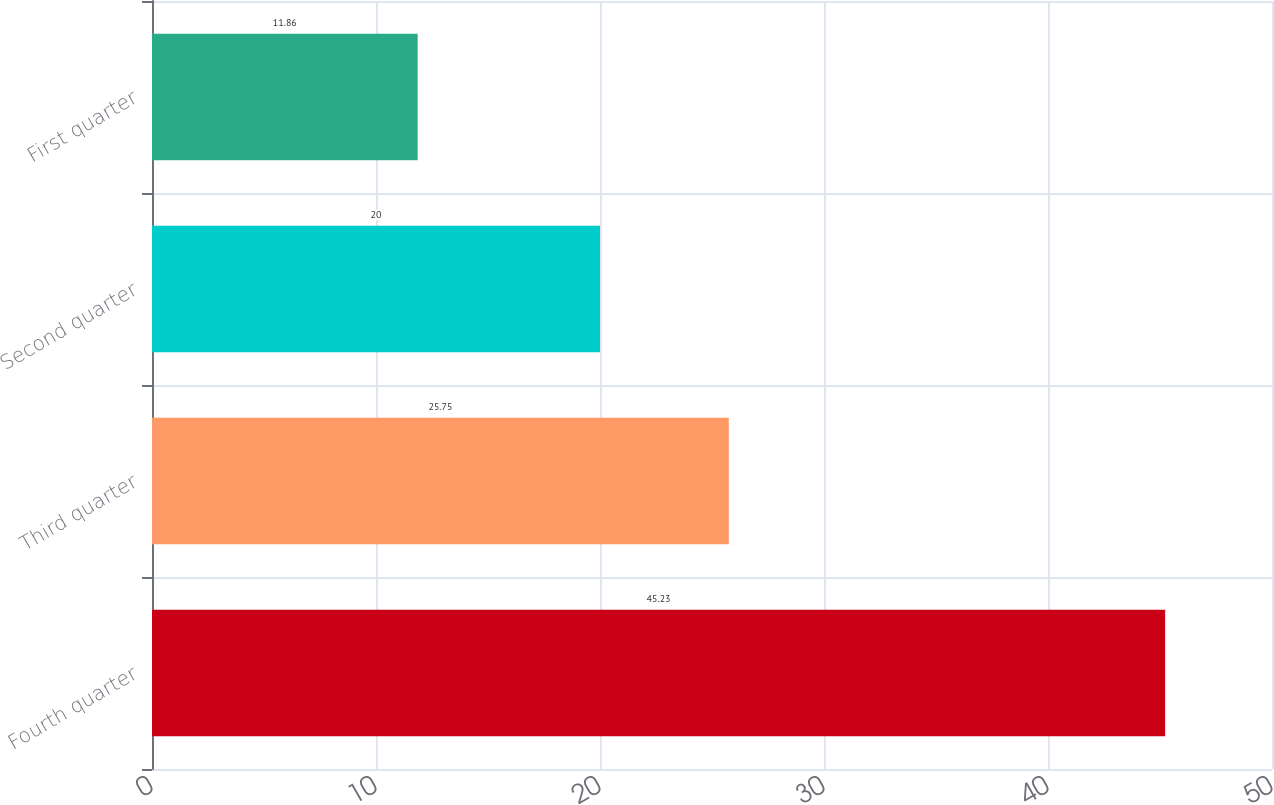Convert chart. <chart><loc_0><loc_0><loc_500><loc_500><bar_chart><fcel>Fourth quarter<fcel>Third quarter<fcel>Second quarter<fcel>First quarter<nl><fcel>45.23<fcel>25.75<fcel>20<fcel>11.86<nl></chart> 